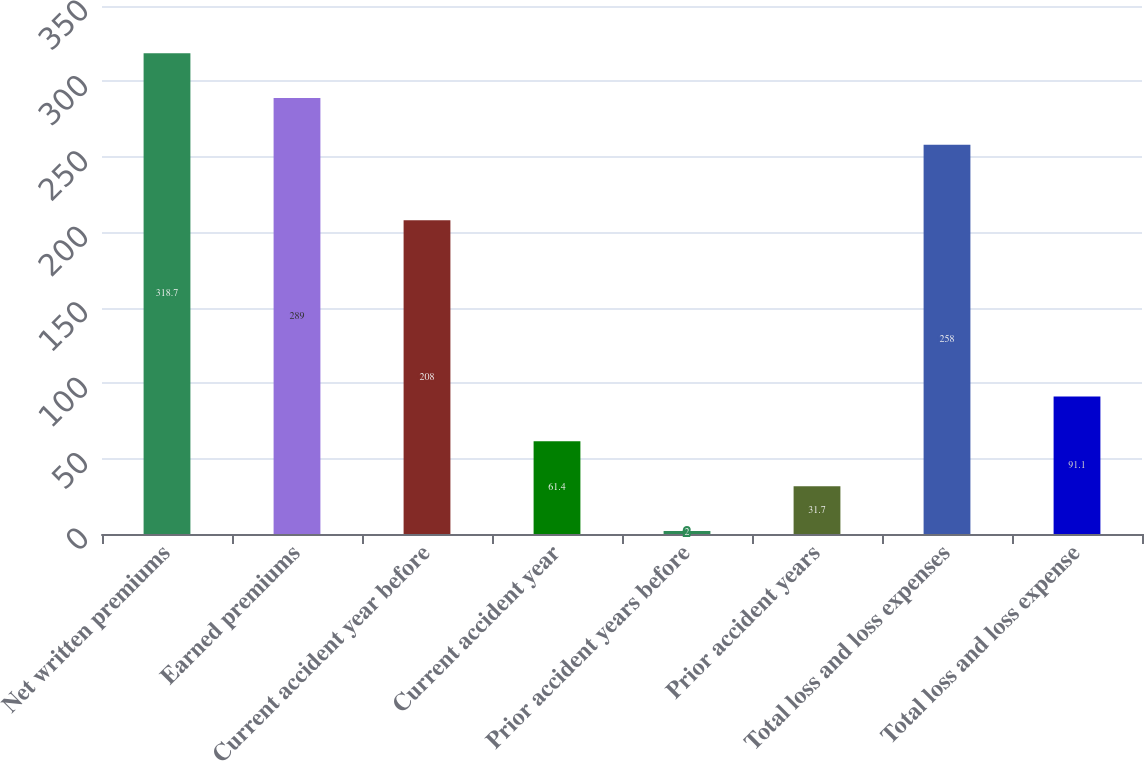Convert chart. <chart><loc_0><loc_0><loc_500><loc_500><bar_chart><fcel>Net written premiums<fcel>Earned premiums<fcel>Current accident year before<fcel>Current accident year<fcel>Prior accident years before<fcel>Prior accident years<fcel>Total loss and loss expenses<fcel>Total loss and loss expense<nl><fcel>318.7<fcel>289<fcel>208<fcel>61.4<fcel>2<fcel>31.7<fcel>258<fcel>91.1<nl></chart> 